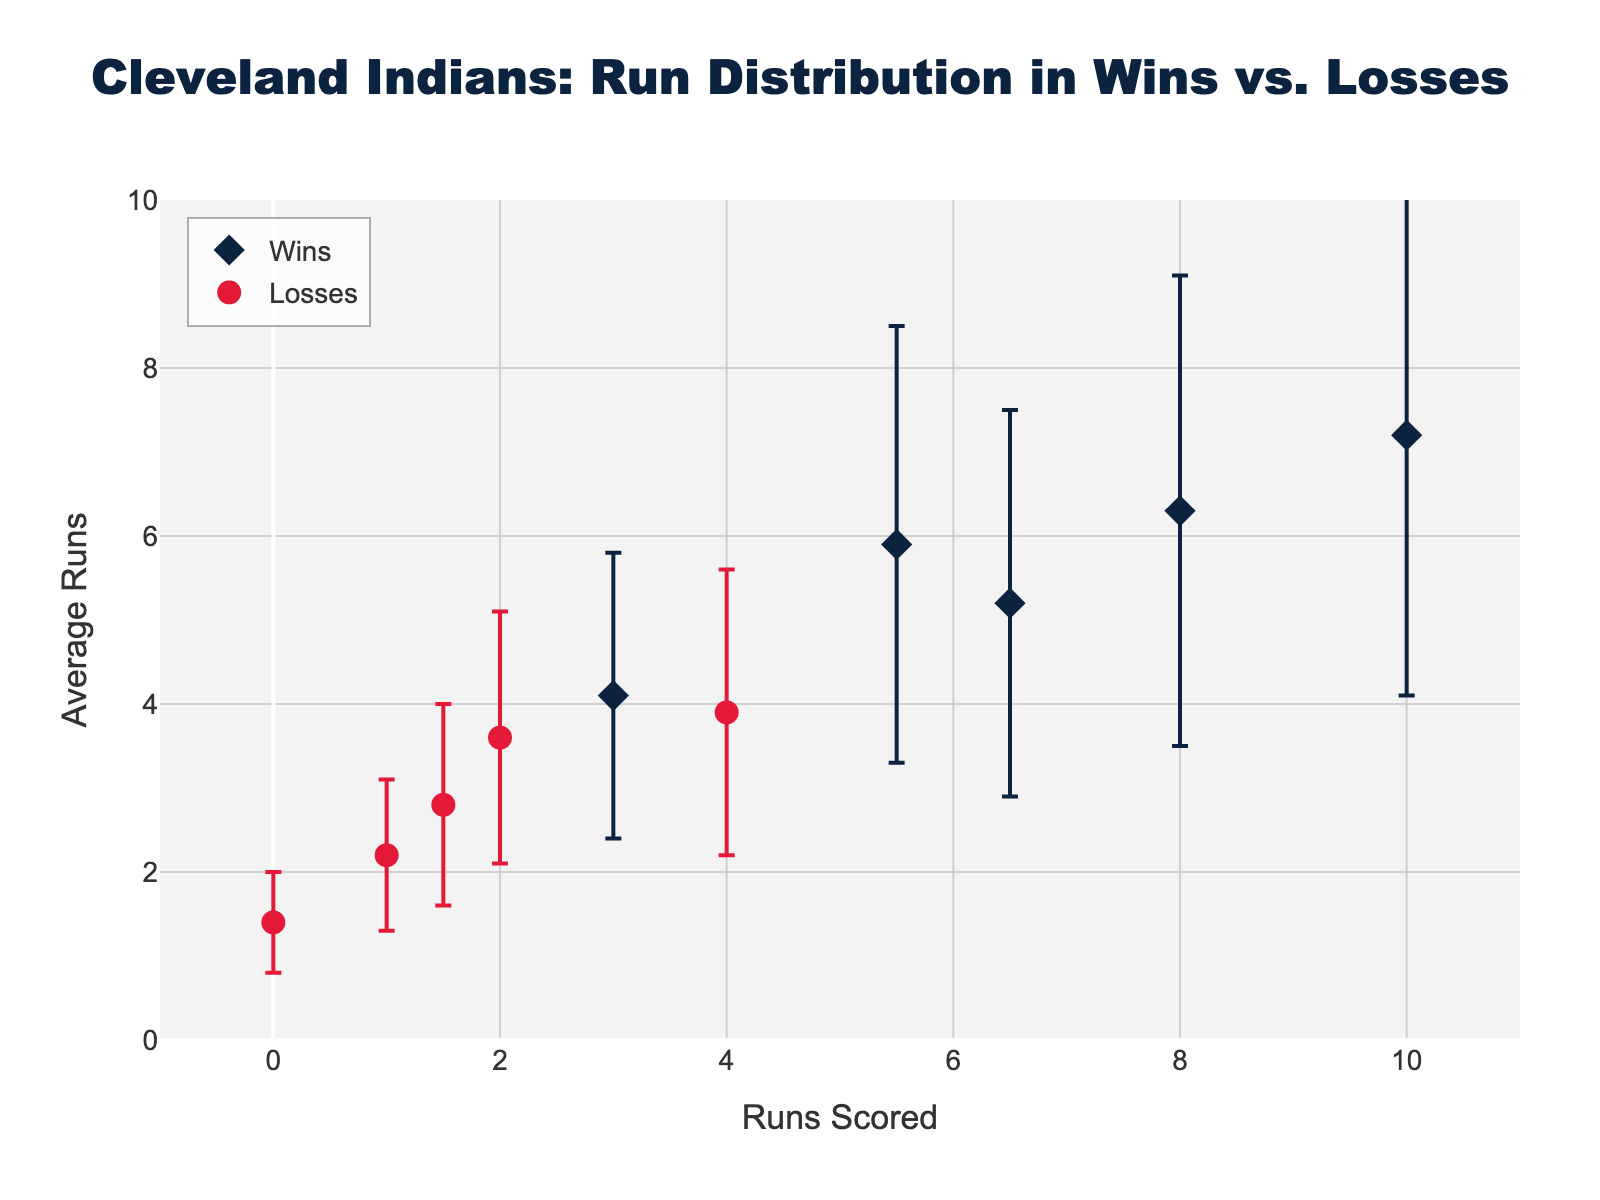what does the title of the figure indicate? The title is "Cleveland Indians: Run Distribution in Wins vs. Losses," indicating the plot compares how runs are distributed between wins and losses for the Cleveland Indians.
Answer: Cleveland Indians: Run Distribution in Wins vs. Losses what runs did the Cleveland Indians score in their wins? The x-axis for wins shows the runs scored were 6.5, 3.0, 8.0, 10.0, and 5.5.
Answer: 6.5, 3.0, 8.0, 10.0, 5.5 what is the average number of runs in losses when they scored 4.0 runs? The y-axis value for losses at 4.0 runs is 3.9. This is the average number of runs in these cases.
Answer: 3.9 which game type has a higher average run per game, wins or losses? By visual inspection, the average runs in wins (mean values on the y-axis for trace 'Wins') are generally higher than those in losses. Thus, wins have higher average runs.
Answer: Wins how many distinct runs values are there for the wins? There are five distinct runs values for wins, as each scatter point represents a unique value: 6.5, 3.0, 8.0, 10.0, and 5.5.
Answer: 5 for which run value do wins have the smallest standard deviation? By looking at the error bars, the smallest standard deviation among wins is for 3.0 runs with a standard deviation of 1.7.
Answer: 3.0 compare the average runs in wins for 5.5 runs and losses for 4.0 runs. Which is higher? The average runs for 5.5 runs in wins is 5.9. For 4.0 runs in losses, it is 3.9. 5.9 is higher than 3.9.
Answer: 5.9 how does the variability in runs compare between wins and losses? By comparing the error bars for both wins and losses, wins generally show greater variability (larger error bars) compared to losses.
Answer: Wins have greater variability which run value in losses shows the highest error margin and what is it? The highest error margin for losses can be observed at 4.0 runs, which has an error margin (standard deviation) of 1.7.
Answer: 1.7 are any of the run values in wins equal to any of those in losses? No, all run values in wins (6.5, 3.0, 8.0, 10.0, 5.5) are different from all run values in losses (2.0, 1.5, 0.0, 4.0, 1.0).
Answer: No 